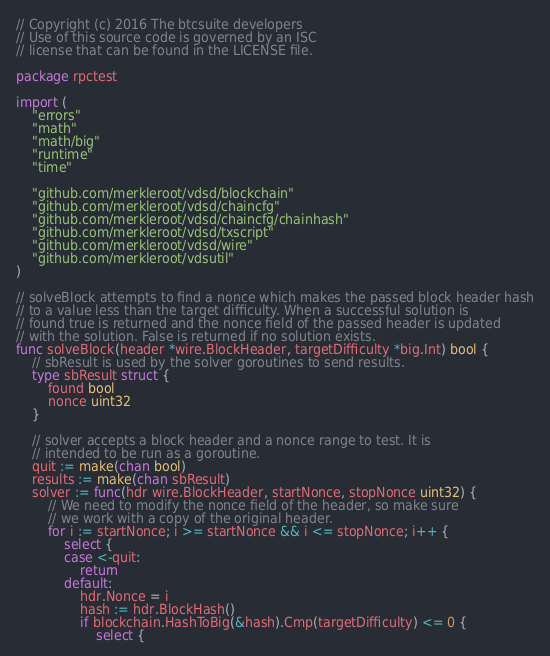<code> <loc_0><loc_0><loc_500><loc_500><_Go_>// Copyright (c) 2016 The btcsuite developers
// Use of this source code is governed by an ISC
// license that can be found in the LICENSE file.

package rpctest

import (
	"errors"
	"math"
	"math/big"
	"runtime"
	"time"

	"github.com/merkleroot/vdsd/blockchain"
	"github.com/merkleroot/vdsd/chaincfg"
	"github.com/merkleroot/vdsd/chaincfg/chainhash"
	"github.com/merkleroot/vdsd/txscript"
	"github.com/merkleroot/vdsd/wire"
	"github.com/merkleroot/vdsutil"
)

// solveBlock attempts to find a nonce which makes the passed block header hash
// to a value less than the target difficulty. When a successful solution is
// found true is returned and the nonce field of the passed header is updated
// with the solution. False is returned if no solution exists.
func solveBlock(header *wire.BlockHeader, targetDifficulty *big.Int) bool {
	// sbResult is used by the solver goroutines to send results.
	type sbResult struct {
		found bool
		nonce uint32
	}

	// solver accepts a block header and a nonce range to test. It is
	// intended to be run as a goroutine.
	quit := make(chan bool)
	results := make(chan sbResult)
	solver := func(hdr wire.BlockHeader, startNonce, stopNonce uint32) {
		// We need to modify the nonce field of the header, so make sure
		// we work with a copy of the original header.
		for i := startNonce; i >= startNonce && i <= stopNonce; i++ {
			select {
			case <-quit:
				return
			default:
				hdr.Nonce = i
				hash := hdr.BlockHash()
				if blockchain.HashToBig(&hash).Cmp(targetDifficulty) <= 0 {
					select {</code> 